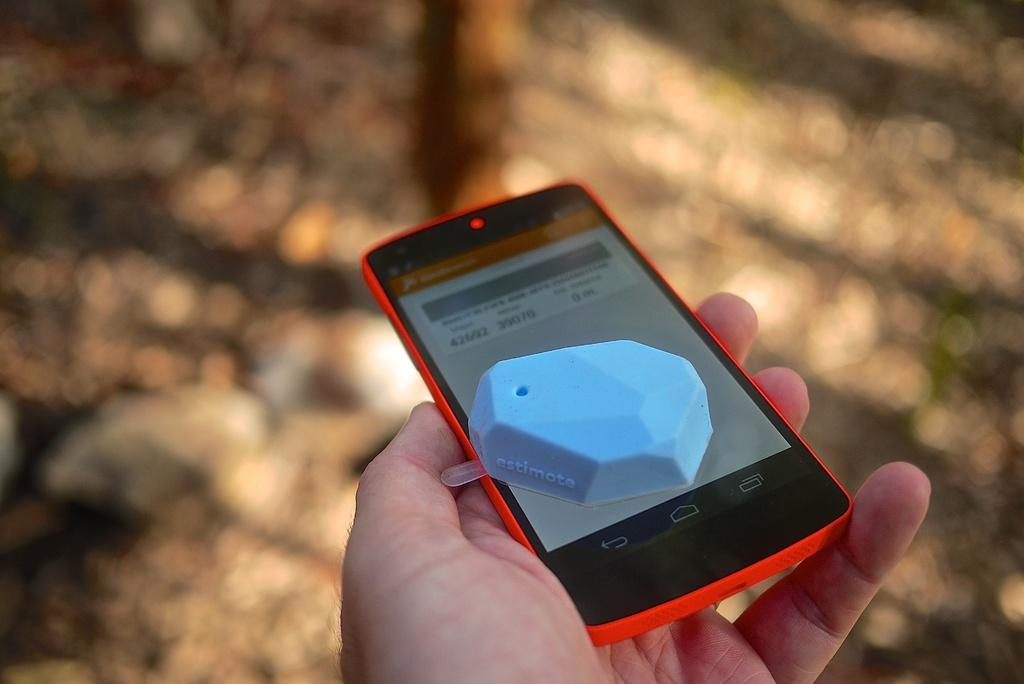<image>
Offer a succinct explanation of the picture presented. a red cell phone with the number 42 on the screen 